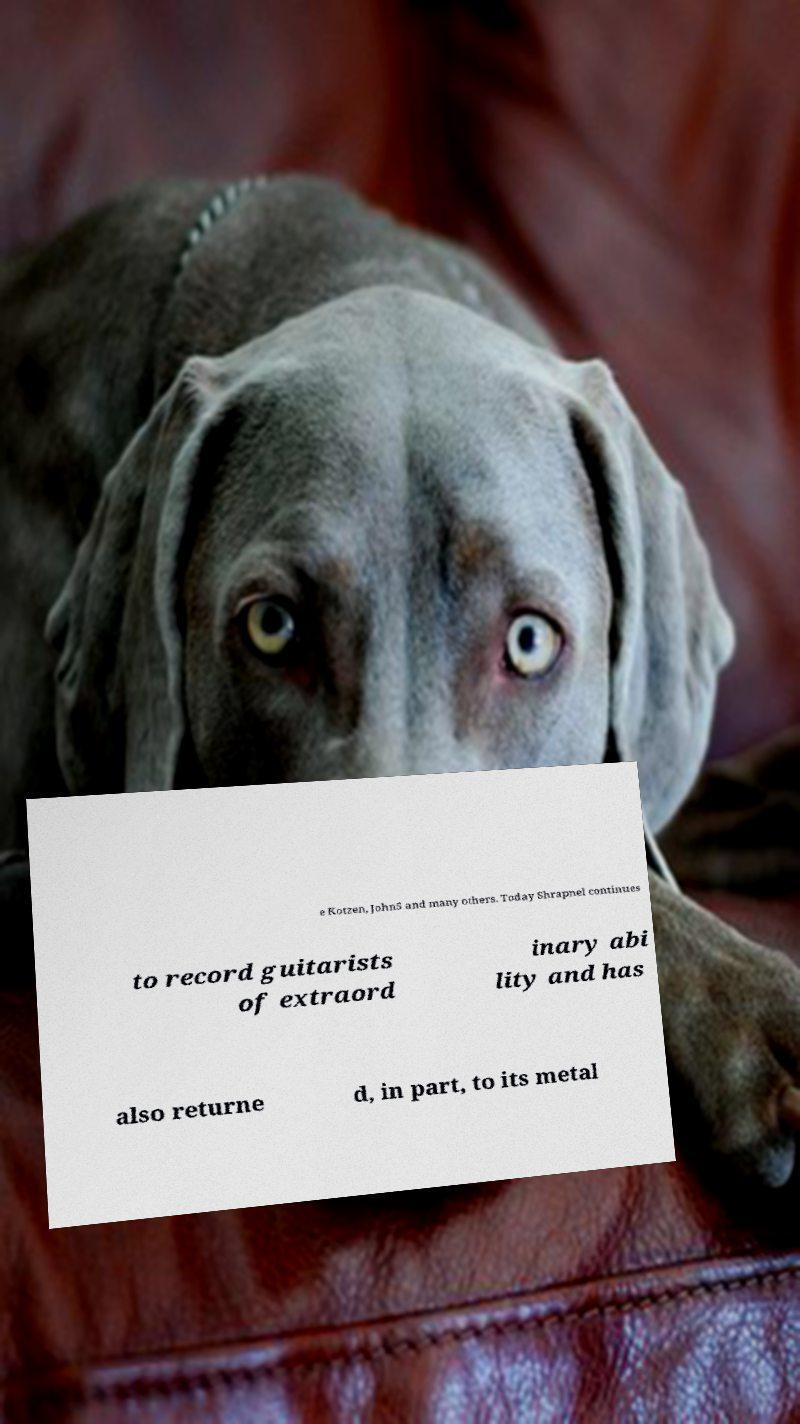What messages or text are displayed in this image? I need them in a readable, typed format. e Kotzen, John5 and many others. Today Shrapnel continues to record guitarists of extraord inary abi lity and has also returne d, in part, to its metal 